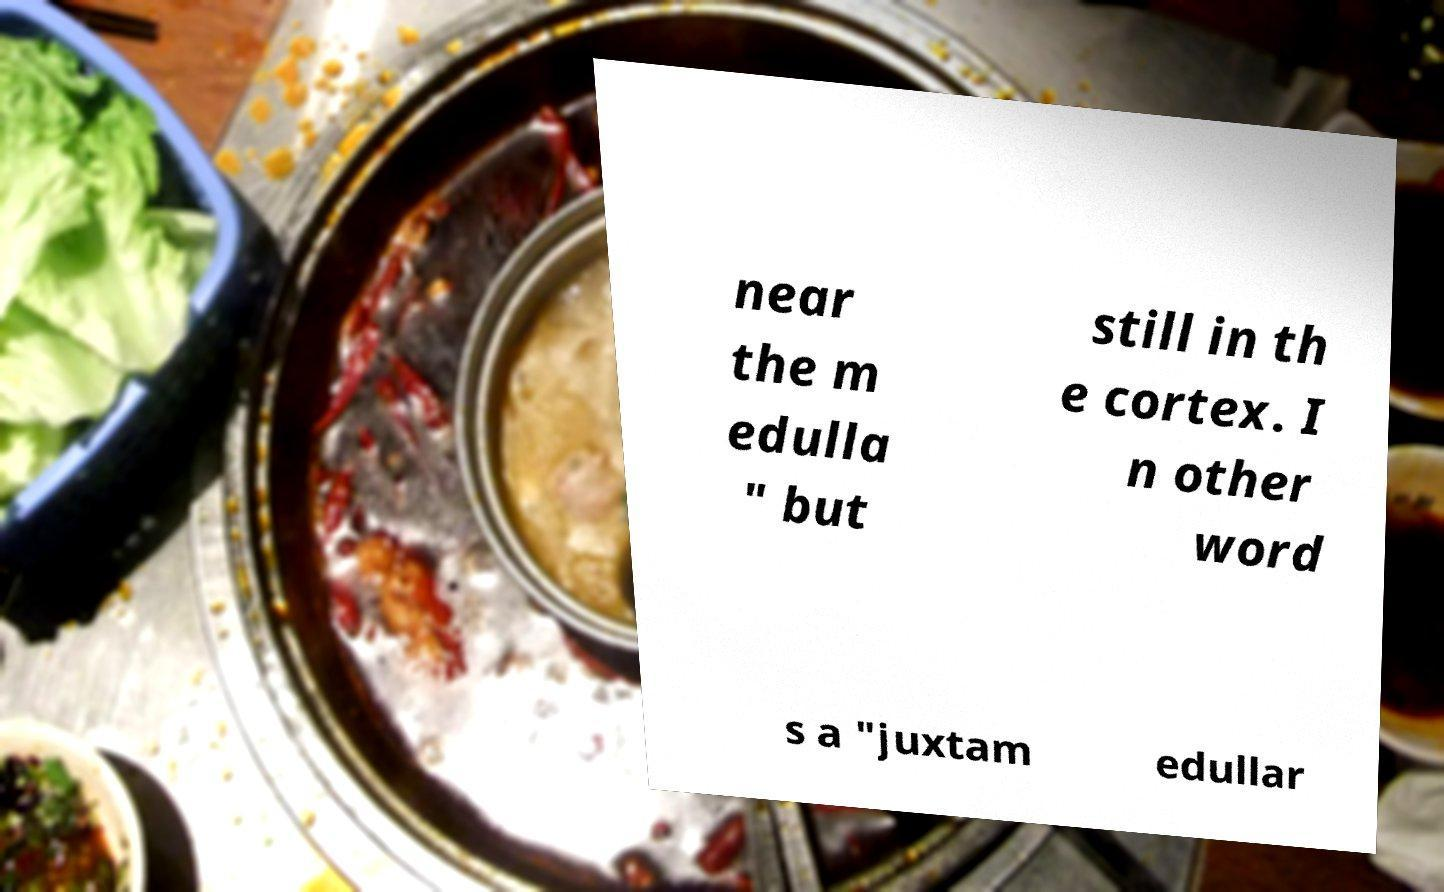There's text embedded in this image that I need extracted. Can you transcribe it verbatim? near the m edulla " but still in th e cortex. I n other word s a "juxtam edullar 